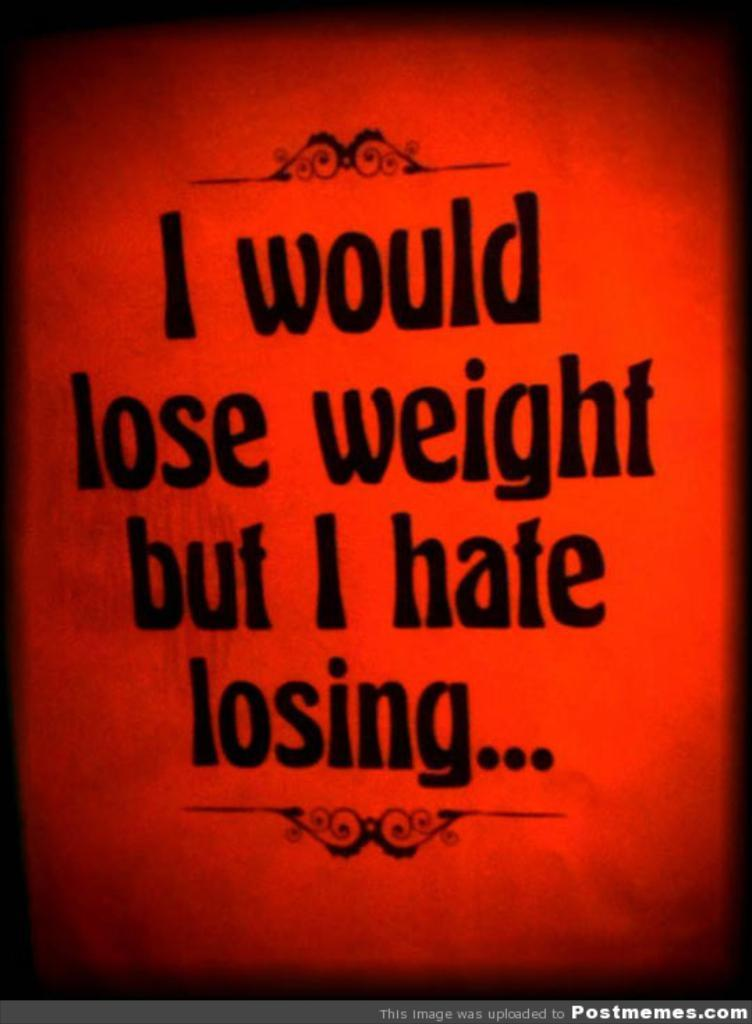<image>
Relay a brief, clear account of the picture shown. a poster that reads i would lose weight but i hate losing 